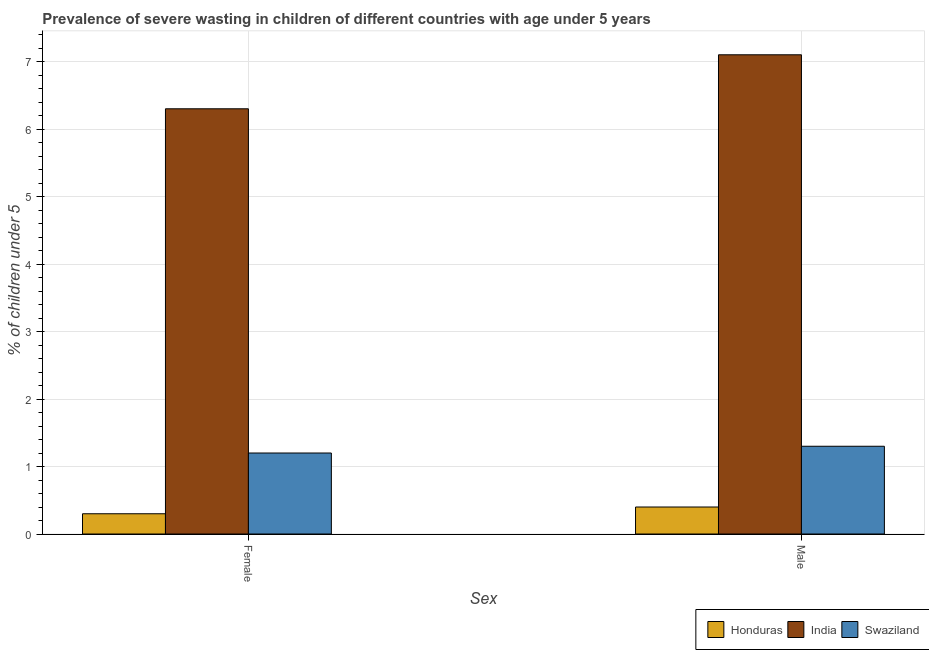Are the number of bars per tick equal to the number of legend labels?
Offer a very short reply. Yes. How many bars are there on the 1st tick from the left?
Offer a very short reply. 3. How many bars are there on the 1st tick from the right?
Keep it short and to the point. 3. What is the percentage of undernourished female children in Swaziland?
Ensure brevity in your answer.  1.2. Across all countries, what is the maximum percentage of undernourished male children?
Your response must be concise. 7.1. Across all countries, what is the minimum percentage of undernourished male children?
Your answer should be compact. 0.4. In which country was the percentage of undernourished female children maximum?
Give a very brief answer. India. In which country was the percentage of undernourished female children minimum?
Offer a very short reply. Honduras. What is the total percentage of undernourished male children in the graph?
Provide a short and direct response. 8.8. What is the difference between the percentage of undernourished male children in Swaziland and that in India?
Provide a succinct answer. -5.8. What is the difference between the percentage of undernourished male children in India and the percentage of undernourished female children in Honduras?
Give a very brief answer. 6.8. What is the average percentage of undernourished male children per country?
Give a very brief answer. 2.93. What is the difference between the percentage of undernourished male children and percentage of undernourished female children in Honduras?
Your response must be concise. 0.1. What is the ratio of the percentage of undernourished female children in Swaziland to that in India?
Your answer should be very brief. 0.19. Is the percentage of undernourished female children in Honduras less than that in India?
Offer a very short reply. Yes. In how many countries, is the percentage of undernourished male children greater than the average percentage of undernourished male children taken over all countries?
Ensure brevity in your answer.  1. What does the 2nd bar from the left in Male represents?
Ensure brevity in your answer.  India. What does the 3rd bar from the right in Male represents?
Provide a short and direct response. Honduras. What is the difference between two consecutive major ticks on the Y-axis?
Keep it short and to the point. 1. Are the values on the major ticks of Y-axis written in scientific E-notation?
Make the answer very short. No. Where does the legend appear in the graph?
Your response must be concise. Bottom right. How are the legend labels stacked?
Keep it short and to the point. Horizontal. What is the title of the graph?
Your response must be concise. Prevalence of severe wasting in children of different countries with age under 5 years. Does "Paraguay" appear as one of the legend labels in the graph?
Provide a short and direct response. No. What is the label or title of the X-axis?
Keep it short and to the point. Sex. What is the label or title of the Y-axis?
Your answer should be very brief.  % of children under 5. What is the  % of children under 5 of Honduras in Female?
Provide a succinct answer. 0.3. What is the  % of children under 5 in India in Female?
Your answer should be very brief. 6.3. What is the  % of children under 5 in Swaziland in Female?
Make the answer very short. 1.2. What is the  % of children under 5 in Honduras in Male?
Provide a succinct answer. 0.4. What is the  % of children under 5 of India in Male?
Provide a succinct answer. 7.1. What is the  % of children under 5 in Swaziland in Male?
Offer a terse response. 1.3. Across all Sex, what is the maximum  % of children under 5 of Honduras?
Provide a succinct answer. 0.4. Across all Sex, what is the maximum  % of children under 5 in India?
Provide a short and direct response. 7.1. Across all Sex, what is the maximum  % of children under 5 in Swaziland?
Give a very brief answer. 1.3. Across all Sex, what is the minimum  % of children under 5 of Honduras?
Ensure brevity in your answer.  0.3. Across all Sex, what is the minimum  % of children under 5 in India?
Offer a very short reply. 6.3. Across all Sex, what is the minimum  % of children under 5 of Swaziland?
Provide a short and direct response. 1.2. What is the total  % of children under 5 in Honduras in the graph?
Provide a succinct answer. 0.7. What is the total  % of children under 5 of India in the graph?
Ensure brevity in your answer.  13.4. What is the difference between the  % of children under 5 in Honduras in Female and that in Male?
Your response must be concise. -0.1. What is the difference between the  % of children under 5 in Swaziland in Female and that in Male?
Provide a succinct answer. -0.1. What is the average  % of children under 5 of Honduras per Sex?
Provide a succinct answer. 0.35. What is the difference between the  % of children under 5 of Honduras and  % of children under 5 of Swaziland in Female?
Make the answer very short. -0.9. What is the difference between the  % of children under 5 of India and  % of children under 5 of Swaziland in Female?
Keep it short and to the point. 5.1. What is the difference between the  % of children under 5 in India and  % of children under 5 in Swaziland in Male?
Offer a very short reply. 5.8. What is the ratio of the  % of children under 5 in India in Female to that in Male?
Offer a terse response. 0.89. What is the difference between the highest and the second highest  % of children under 5 of Swaziland?
Provide a succinct answer. 0.1. What is the difference between the highest and the lowest  % of children under 5 in Swaziland?
Offer a very short reply. 0.1. 